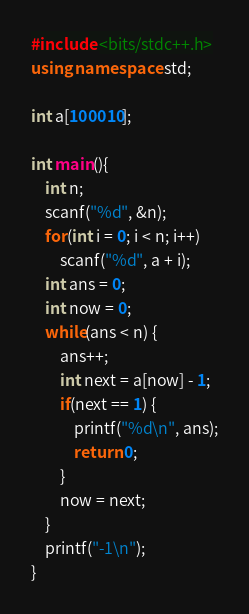Convert code to text. <code><loc_0><loc_0><loc_500><loc_500><_C++_>#include <bits/stdc++.h>
using namespace std;

int a[100010];

int main(){
	int n;
	scanf("%d", &n);
	for(int i = 0; i < n; i++)
		scanf("%d", a + i);
	int ans = 0;
	int now = 0;
	while(ans < n) {
		ans++;
		int next = a[now] - 1;
		if(next == 1) {
			printf("%d\n", ans);
			return 0;
		}
		now = next;
	}
	printf("-1\n");
}
</code> 